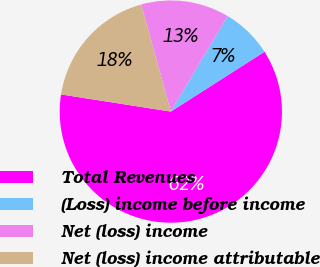<chart> <loc_0><loc_0><loc_500><loc_500><pie_chart><fcel>Total Revenues<fcel>(Loss) income before income<fcel>Net (loss) income<fcel>Net (loss) income attributable<nl><fcel>61.51%<fcel>7.42%<fcel>12.83%<fcel>18.24%<nl></chart> 